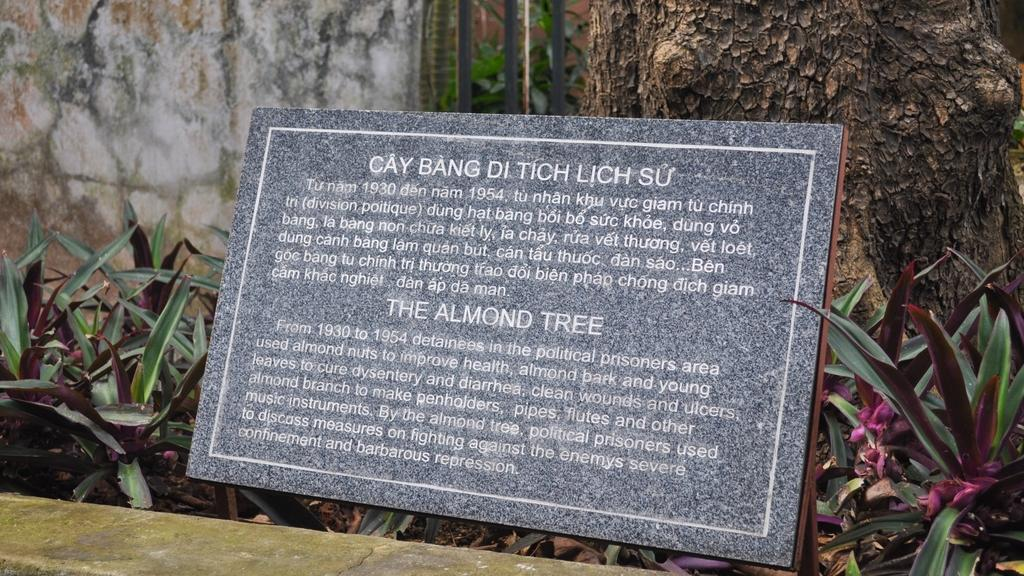What is the main object in the image? There is a commemorative plaque in the image. What can be found on the plaque? The plaque has text on it. What type of vegetation is near the plaque? There are plants near the plaque. What other natural element is in the vicinity of the plaque? There is a tree in the vicinity of the plaque. What architectural feature is in front of the plaque? There is a wall in front of the plaque. What can be seen in the background of the image? There is a wall visible in the background of the image. What type of pancake is being served on the plaque in the image? There is no pancake present in the image; it features a commemorative plaque with text on it. What force is causing the plaque to levitate in the image? There is no indication in the image that the plaque is levitating, and no force is mentioned or implied. 